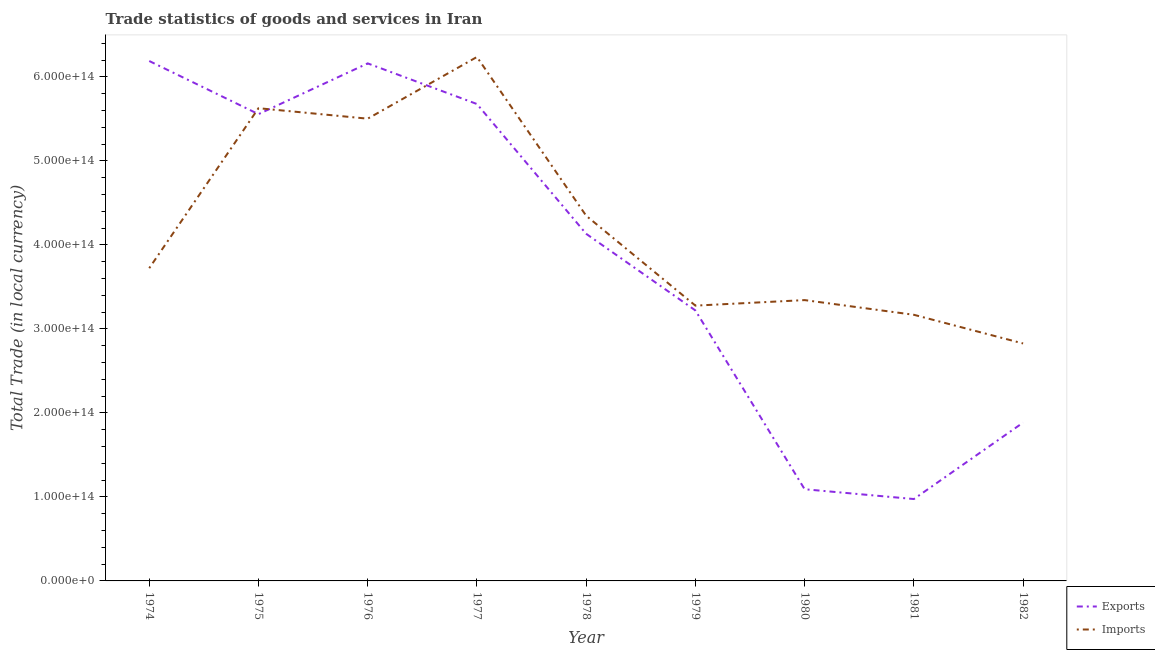Does the line corresponding to export of goods and services intersect with the line corresponding to imports of goods and services?
Your answer should be compact. Yes. What is the imports of goods and services in 1975?
Ensure brevity in your answer.  5.63e+14. Across all years, what is the maximum export of goods and services?
Offer a terse response. 6.19e+14. Across all years, what is the minimum export of goods and services?
Ensure brevity in your answer.  9.75e+13. In which year was the export of goods and services maximum?
Make the answer very short. 1974. What is the total imports of goods and services in the graph?
Your answer should be compact. 3.81e+15. What is the difference between the export of goods and services in 1974 and that in 1982?
Keep it short and to the point. 4.30e+14. What is the difference between the imports of goods and services in 1980 and the export of goods and services in 1979?
Make the answer very short. 1.23e+13. What is the average imports of goods and services per year?
Offer a terse response. 4.23e+14. In the year 1978, what is the difference between the export of goods and services and imports of goods and services?
Provide a succinct answer. -2.15e+13. In how many years, is the imports of goods and services greater than 40000000000000 LCU?
Give a very brief answer. 9. What is the ratio of the imports of goods and services in 1976 to that in 1981?
Your response must be concise. 1.74. Is the imports of goods and services in 1977 less than that in 1981?
Keep it short and to the point. No. What is the difference between the highest and the second highest export of goods and services?
Your answer should be compact. 2.84e+12. What is the difference between the highest and the lowest imports of goods and services?
Offer a terse response. 3.41e+14. Is the sum of the imports of goods and services in 1976 and 1977 greater than the maximum export of goods and services across all years?
Provide a short and direct response. Yes. Does the imports of goods and services monotonically increase over the years?
Your response must be concise. No. Is the export of goods and services strictly greater than the imports of goods and services over the years?
Keep it short and to the point. No. Is the export of goods and services strictly less than the imports of goods and services over the years?
Provide a short and direct response. No. How many lines are there?
Offer a terse response. 2. What is the difference between two consecutive major ticks on the Y-axis?
Give a very brief answer. 1.00e+14. Are the values on the major ticks of Y-axis written in scientific E-notation?
Give a very brief answer. Yes. What is the title of the graph?
Offer a very short reply. Trade statistics of goods and services in Iran. Does "Automatic Teller Machines" appear as one of the legend labels in the graph?
Provide a short and direct response. No. What is the label or title of the Y-axis?
Keep it short and to the point. Total Trade (in local currency). What is the Total Trade (in local currency) of Exports in 1974?
Your response must be concise. 6.19e+14. What is the Total Trade (in local currency) in Imports in 1974?
Provide a short and direct response. 3.72e+14. What is the Total Trade (in local currency) in Exports in 1975?
Your answer should be very brief. 5.56e+14. What is the Total Trade (in local currency) in Imports in 1975?
Your answer should be compact. 5.63e+14. What is the Total Trade (in local currency) of Exports in 1976?
Provide a succinct answer. 6.16e+14. What is the Total Trade (in local currency) in Imports in 1976?
Your response must be concise. 5.50e+14. What is the Total Trade (in local currency) in Exports in 1977?
Offer a very short reply. 5.68e+14. What is the Total Trade (in local currency) of Imports in 1977?
Your response must be concise. 6.24e+14. What is the Total Trade (in local currency) in Exports in 1978?
Provide a succinct answer. 4.13e+14. What is the Total Trade (in local currency) of Imports in 1978?
Keep it short and to the point. 4.35e+14. What is the Total Trade (in local currency) of Exports in 1979?
Ensure brevity in your answer.  3.22e+14. What is the Total Trade (in local currency) in Imports in 1979?
Offer a very short reply. 3.28e+14. What is the Total Trade (in local currency) of Exports in 1980?
Keep it short and to the point. 1.09e+14. What is the Total Trade (in local currency) of Imports in 1980?
Your answer should be very brief. 3.34e+14. What is the Total Trade (in local currency) in Exports in 1981?
Provide a short and direct response. 9.75e+13. What is the Total Trade (in local currency) of Imports in 1981?
Your response must be concise. 3.17e+14. What is the Total Trade (in local currency) in Exports in 1982?
Offer a very short reply. 1.88e+14. What is the Total Trade (in local currency) of Imports in 1982?
Your response must be concise. 2.83e+14. Across all years, what is the maximum Total Trade (in local currency) of Exports?
Your answer should be very brief. 6.19e+14. Across all years, what is the maximum Total Trade (in local currency) of Imports?
Keep it short and to the point. 6.24e+14. Across all years, what is the minimum Total Trade (in local currency) in Exports?
Offer a terse response. 9.75e+13. Across all years, what is the minimum Total Trade (in local currency) in Imports?
Offer a very short reply. 2.83e+14. What is the total Total Trade (in local currency) in Exports in the graph?
Provide a short and direct response. 3.49e+15. What is the total Total Trade (in local currency) of Imports in the graph?
Make the answer very short. 3.81e+15. What is the difference between the Total Trade (in local currency) of Exports in 1974 and that in 1975?
Make the answer very short. 6.33e+13. What is the difference between the Total Trade (in local currency) in Imports in 1974 and that in 1975?
Your response must be concise. -1.90e+14. What is the difference between the Total Trade (in local currency) of Exports in 1974 and that in 1976?
Keep it short and to the point. 2.84e+12. What is the difference between the Total Trade (in local currency) in Imports in 1974 and that in 1976?
Offer a terse response. -1.78e+14. What is the difference between the Total Trade (in local currency) of Exports in 1974 and that in 1977?
Make the answer very short. 5.12e+13. What is the difference between the Total Trade (in local currency) of Imports in 1974 and that in 1977?
Make the answer very short. -2.51e+14. What is the difference between the Total Trade (in local currency) in Exports in 1974 and that in 1978?
Keep it short and to the point. 2.06e+14. What is the difference between the Total Trade (in local currency) of Imports in 1974 and that in 1978?
Your response must be concise. -6.24e+13. What is the difference between the Total Trade (in local currency) in Exports in 1974 and that in 1979?
Provide a succinct answer. 2.97e+14. What is the difference between the Total Trade (in local currency) in Imports in 1974 and that in 1979?
Offer a terse response. 4.46e+13. What is the difference between the Total Trade (in local currency) of Exports in 1974 and that in 1980?
Keep it short and to the point. 5.10e+14. What is the difference between the Total Trade (in local currency) in Imports in 1974 and that in 1980?
Your answer should be very brief. 3.80e+13. What is the difference between the Total Trade (in local currency) in Exports in 1974 and that in 1981?
Provide a succinct answer. 5.21e+14. What is the difference between the Total Trade (in local currency) in Imports in 1974 and that in 1981?
Make the answer very short. 5.55e+13. What is the difference between the Total Trade (in local currency) in Exports in 1974 and that in 1982?
Ensure brevity in your answer.  4.30e+14. What is the difference between the Total Trade (in local currency) in Imports in 1974 and that in 1982?
Provide a short and direct response. 8.96e+13. What is the difference between the Total Trade (in local currency) of Exports in 1975 and that in 1976?
Make the answer very short. -6.04e+13. What is the difference between the Total Trade (in local currency) of Imports in 1975 and that in 1976?
Give a very brief answer. 1.25e+13. What is the difference between the Total Trade (in local currency) of Exports in 1975 and that in 1977?
Make the answer very short. -1.21e+13. What is the difference between the Total Trade (in local currency) of Imports in 1975 and that in 1977?
Offer a very short reply. -6.10e+13. What is the difference between the Total Trade (in local currency) of Exports in 1975 and that in 1978?
Offer a terse response. 1.42e+14. What is the difference between the Total Trade (in local currency) in Imports in 1975 and that in 1978?
Provide a succinct answer. 1.28e+14. What is the difference between the Total Trade (in local currency) of Exports in 1975 and that in 1979?
Offer a terse response. 2.34e+14. What is the difference between the Total Trade (in local currency) in Imports in 1975 and that in 1979?
Provide a short and direct response. 2.35e+14. What is the difference between the Total Trade (in local currency) in Exports in 1975 and that in 1980?
Make the answer very short. 4.47e+14. What is the difference between the Total Trade (in local currency) in Imports in 1975 and that in 1980?
Your answer should be compact. 2.28e+14. What is the difference between the Total Trade (in local currency) of Exports in 1975 and that in 1981?
Your response must be concise. 4.58e+14. What is the difference between the Total Trade (in local currency) of Imports in 1975 and that in 1981?
Provide a succinct answer. 2.46e+14. What is the difference between the Total Trade (in local currency) in Exports in 1975 and that in 1982?
Provide a short and direct response. 3.67e+14. What is the difference between the Total Trade (in local currency) in Imports in 1975 and that in 1982?
Make the answer very short. 2.80e+14. What is the difference between the Total Trade (in local currency) in Exports in 1976 and that in 1977?
Offer a very short reply. 4.84e+13. What is the difference between the Total Trade (in local currency) in Imports in 1976 and that in 1977?
Offer a terse response. -7.34e+13. What is the difference between the Total Trade (in local currency) of Exports in 1976 and that in 1978?
Ensure brevity in your answer.  2.03e+14. What is the difference between the Total Trade (in local currency) of Imports in 1976 and that in 1978?
Offer a terse response. 1.16e+14. What is the difference between the Total Trade (in local currency) of Exports in 1976 and that in 1979?
Your answer should be very brief. 2.94e+14. What is the difference between the Total Trade (in local currency) of Imports in 1976 and that in 1979?
Your response must be concise. 2.23e+14. What is the difference between the Total Trade (in local currency) in Exports in 1976 and that in 1980?
Make the answer very short. 5.07e+14. What is the difference between the Total Trade (in local currency) of Imports in 1976 and that in 1980?
Make the answer very short. 2.16e+14. What is the difference between the Total Trade (in local currency) of Exports in 1976 and that in 1981?
Offer a very short reply. 5.19e+14. What is the difference between the Total Trade (in local currency) of Imports in 1976 and that in 1981?
Your answer should be very brief. 2.33e+14. What is the difference between the Total Trade (in local currency) of Exports in 1976 and that in 1982?
Provide a succinct answer. 4.28e+14. What is the difference between the Total Trade (in local currency) of Imports in 1976 and that in 1982?
Offer a very short reply. 2.68e+14. What is the difference between the Total Trade (in local currency) of Exports in 1977 and that in 1978?
Offer a terse response. 1.55e+14. What is the difference between the Total Trade (in local currency) of Imports in 1977 and that in 1978?
Provide a succinct answer. 1.89e+14. What is the difference between the Total Trade (in local currency) of Exports in 1977 and that in 1979?
Offer a very short reply. 2.46e+14. What is the difference between the Total Trade (in local currency) of Imports in 1977 and that in 1979?
Make the answer very short. 2.96e+14. What is the difference between the Total Trade (in local currency) in Exports in 1977 and that in 1980?
Your answer should be compact. 4.59e+14. What is the difference between the Total Trade (in local currency) of Imports in 1977 and that in 1980?
Give a very brief answer. 2.89e+14. What is the difference between the Total Trade (in local currency) of Exports in 1977 and that in 1981?
Offer a terse response. 4.70e+14. What is the difference between the Total Trade (in local currency) in Imports in 1977 and that in 1981?
Offer a terse response. 3.07e+14. What is the difference between the Total Trade (in local currency) of Exports in 1977 and that in 1982?
Your answer should be very brief. 3.79e+14. What is the difference between the Total Trade (in local currency) in Imports in 1977 and that in 1982?
Provide a succinct answer. 3.41e+14. What is the difference between the Total Trade (in local currency) of Exports in 1978 and that in 1979?
Provide a short and direct response. 9.12e+13. What is the difference between the Total Trade (in local currency) in Imports in 1978 and that in 1979?
Offer a terse response. 1.07e+14. What is the difference between the Total Trade (in local currency) of Exports in 1978 and that in 1980?
Make the answer very short. 3.04e+14. What is the difference between the Total Trade (in local currency) in Imports in 1978 and that in 1980?
Keep it short and to the point. 1.00e+14. What is the difference between the Total Trade (in local currency) in Exports in 1978 and that in 1981?
Ensure brevity in your answer.  3.16e+14. What is the difference between the Total Trade (in local currency) in Imports in 1978 and that in 1981?
Offer a terse response. 1.18e+14. What is the difference between the Total Trade (in local currency) of Exports in 1978 and that in 1982?
Ensure brevity in your answer.  2.25e+14. What is the difference between the Total Trade (in local currency) in Imports in 1978 and that in 1982?
Offer a very short reply. 1.52e+14. What is the difference between the Total Trade (in local currency) in Exports in 1979 and that in 1980?
Offer a very short reply. 2.13e+14. What is the difference between the Total Trade (in local currency) in Imports in 1979 and that in 1980?
Provide a short and direct response. -6.57e+12. What is the difference between the Total Trade (in local currency) of Exports in 1979 and that in 1981?
Your response must be concise. 2.25e+14. What is the difference between the Total Trade (in local currency) of Imports in 1979 and that in 1981?
Your response must be concise. 1.09e+13. What is the difference between the Total Trade (in local currency) of Exports in 1979 and that in 1982?
Provide a short and direct response. 1.34e+14. What is the difference between the Total Trade (in local currency) in Imports in 1979 and that in 1982?
Provide a short and direct response. 4.51e+13. What is the difference between the Total Trade (in local currency) in Exports in 1980 and that in 1981?
Your answer should be compact. 1.17e+13. What is the difference between the Total Trade (in local currency) in Imports in 1980 and that in 1981?
Your answer should be compact. 1.75e+13. What is the difference between the Total Trade (in local currency) of Exports in 1980 and that in 1982?
Your response must be concise. -7.93e+13. What is the difference between the Total Trade (in local currency) in Imports in 1980 and that in 1982?
Give a very brief answer. 5.16e+13. What is the difference between the Total Trade (in local currency) in Exports in 1981 and that in 1982?
Your response must be concise. -9.10e+13. What is the difference between the Total Trade (in local currency) of Imports in 1981 and that in 1982?
Your answer should be compact. 3.41e+13. What is the difference between the Total Trade (in local currency) of Exports in 1974 and the Total Trade (in local currency) of Imports in 1975?
Ensure brevity in your answer.  5.62e+13. What is the difference between the Total Trade (in local currency) in Exports in 1974 and the Total Trade (in local currency) in Imports in 1976?
Provide a short and direct response. 6.87e+13. What is the difference between the Total Trade (in local currency) in Exports in 1974 and the Total Trade (in local currency) in Imports in 1977?
Your response must be concise. -4.80e+12. What is the difference between the Total Trade (in local currency) in Exports in 1974 and the Total Trade (in local currency) in Imports in 1978?
Offer a terse response. 1.84e+14. What is the difference between the Total Trade (in local currency) in Exports in 1974 and the Total Trade (in local currency) in Imports in 1979?
Keep it short and to the point. 2.91e+14. What is the difference between the Total Trade (in local currency) of Exports in 1974 and the Total Trade (in local currency) of Imports in 1980?
Your answer should be compact. 2.85e+14. What is the difference between the Total Trade (in local currency) of Exports in 1974 and the Total Trade (in local currency) of Imports in 1981?
Provide a short and direct response. 3.02e+14. What is the difference between the Total Trade (in local currency) in Exports in 1974 and the Total Trade (in local currency) in Imports in 1982?
Offer a terse response. 3.36e+14. What is the difference between the Total Trade (in local currency) of Exports in 1975 and the Total Trade (in local currency) of Imports in 1976?
Offer a very short reply. 5.38e+12. What is the difference between the Total Trade (in local currency) of Exports in 1975 and the Total Trade (in local currency) of Imports in 1977?
Offer a terse response. -6.81e+13. What is the difference between the Total Trade (in local currency) of Exports in 1975 and the Total Trade (in local currency) of Imports in 1978?
Offer a terse response. 1.21e+14. What is the difference between the Total Trade (in local currency) of Exports in 1975 and the Total Trade (in local currency) of Imports in 1979?
Offer a terse response. 2.28e+14. What is the difference between the Total Trade (in local currency) of Exports in 1975 and the Total Trade (in local currency) of Imports in 1980?
Your answer should be compact. 2.21e+14. What is the difference between the Total Trade (in local currency) of Exports in 1975 and the Total Trade (in local currency) of Imports in 1981?
Your answer should be compact. 2.39e+14. What is the difference between the Total Trade (in local currency) in Exports in 1975 and the Total Trade (in local currency) in Imports in 1982?
Your answer should be very brief. 2.73e+14. What is the difference between the Total Trade (in local currency) of Exports in 1976 and the Total Trade (in local currency) of Imports in 1977?
Make the answer very short. -7.63e+12. What is the difference between the Total Trade (in local currency) in Exports in 1976 and the Total Trade (in local currency) in Imports in 1978?
Provide a succinct answer. 1.81e+14. What is the difference between the Total Trade (in local currency) in Exports in 1976 and the Total Trade (in local currency) in Imports in 1979?
Make the answer very short. 2.88e+14. What is the difference between the Total Trade (in local currency) of Exports in 1976 and the Total Trade (in local currency) of Imports in 1980?
Your answer should be compact. 2.82e+14. What is the difference between the Total Trade (in local currency) of Exports in 1976 and the Total Trade (in local currency) of Imports in 1981?
Keep it short and to the point. 2.99e+14. What is the difference between the Total Trade (in local currency) in Exports in 1976 and the Total Trade (in local currency) in Imports in 1982?
Your answer should be compact. 3.33e+14. What is the difference between the Total Trade (in local currency) of Exports in 1977 and the Total Trade (in local currency) of Imports in 1978?
Offer a terse response. 1.33e+14. What is the difference between the Total Trade (in local currency) of Exports in 1977 and the Total Trade (in local currency) of Imports in 1979?
Provide a short and direct response. 2.40e+14. What is the difference between the Total Trade (in local currency) of Exports in 1977 and the Total Trade (in local currency) of Imports in 1980?
Your answer should be compact. 2.33e+14. What is the difference between the Total Trade (in local currency) in Exports in 1977 and the Total Trade (in local currency) in Imports in 1981?
Provide a short and direct response. 2.51e+14. What is the difference between the Total Trade (in local currency) in Exports in 1977 and the Total Trade (in local currency) in Imports in 1982?
Offer a terse response. 2.85e+14. What is the difference between the Total Trade (in local currency) in Exports in 1978 and the Total Trade (in local currency) in Imports in 1979?
Your response must be concise. 8.55e+13. What is the difference between the Total Trade (in local currency) in Exports in 1978 and the Total Trade (in local currency) in Imports in 1980?
Your answer should be very brief. 7.89e+13. What is the difference between the Total Trade (in local currency) in Exports in 1978 and the Total Trade (in local currency) in Imports in 1981?
Make the answer very short. 9.64e+13. What is the difference between the Total Trade (in local currency) in Exports in 1978 and the Total Trade (in local currency) in Imports in 1982?
Ensure brevity in your answer.  1.31e+14. What is the difference between the Total Trade (in local currency) in Exports in 1979 and the Total Trade (in local currency) in Imports in 1980?
Offer a terse response. -1.23e+13. What is the difference between the Total Trade (in local currency) in Exports in 1979 and the Total Trade (in local currency) in Imports in 1981?
Your response must be concise. 5.17e+12. What is the difference between the Total Trade (in local currency) in Exports in 1979 and the Total Trade (in local currency) in Imports in 1982?
Offer a very short reply. 3.93e+13. What is the difference between the Total Trade (in local currency) of Exports in 1980 and the Total Trade (in local currency) of Imports in 1981?
Offer a very short reply. -2.08e+14. What is the difference between the Total Trade (in local currency) of Exports in 1980 and the Total Trade (in local currency) of Imports in 1982?
Your response must be concise. -1.74e+14. What is the difference between the Total Trade (in local currency) of Exports in 1981 and the Total Trade (in local currency) of Imports in 1982?
Keep it short and to the point. -1.85e+14. What is the average Total Trade (in local currency) in Exports per year?
Give a very brief answer. 3.88e+14. What is the average Total Trade (in local currency) of Imports per year?
Keep it short and to the point. 4.23e+14. In the year 1974, what is the difference between the Total Trade (in local currency) in Exports and Total Trade (in local currency) in Imports?
Your answer should be compact. 2.47e+14. In the year 1975, what is the difference between the Total Trade (in local currency) of Exports and Total Trade (in local currency) of Imports?
Provide a succinct answer. -7.09e+12. In the year 1976, what is the difference between the Total Trade (in local currency) of Exports and Total Trade (in local currency) of Imports?
Provide a short and direct response. 6.58e+13. In the year 1977, what is the difference between the Total Trade (in local currency) in Exports and Total Trade (in local currency) in Imports?
Offer a terse response. -5.60e+13. In the year 1978, what is the difference between the Total Trade (in local currency) in Exports and Total Trade (in local currency) in Imports?
Keep it short and to the point. -2.15e+13. In the year 1979, what is the difference between the Total Trade (in local currency) of Exports and Total Trade (in local currency) of Imports?
Give a very brief answer. -5.74e+12. In the year 1980, what is the difference between the Total Trade (in local currency) in Exports and Total Trade (in local currency) in Imports?
Your answer should be compact. -2.25e+14. In the year 1981, what is the difference between the Total Trade (in local currency) in Exports and Total Trade (in local currency) in Imports?
Your response must be concise. -2.19e+14. In the year 1982, what is the difference between the Total Trade (in local currency) in Exports and Total Trade (in local currency) in Imports?
Offer a terse response. -9.42e+13. What is the ratio of the Total Trade (in local currency) in Exports in 1974 to that in 1975?
Your answer should be compact. 1.11. What is the ratio of the Total Trade (in local currency) of Imports in 1974 to that in 1975?
Offer a very short reply. 0.66. What is the ratio of the Total Trade (in local currency) in Imports in 1974 to that in 1976?
Provide a succinct answer. 0.68. What is the ratio of the Total Trade (in local currency) of Exports in 1974 to that in 1977?
Offer a very short reply. 1.09. What is the ratio of the Total Trade (in local currency) in Imports in 1974 to that in 1977?
Give a very brief answer. 0.6. What is the ratio of the Total Trade (in local currency) of Exports in 1974 to that in 1978?
Your response must be concise. 1.5. What is the ratio of the Total Trade (in local currency) of Imports in 1974 to that in 1978?
Your answer should be very brief. 0.86. What is the ratio of the Total Trade (in local currency) in Exports in 1974 to that in 1979?
Ensure brevity in your answer.  1.92. What is the ratio of the Total Trade (in local currency) in Imports in 1974 to that in 1979?
Offer a terse response. 1.14. What is the ratio of the Total Trade (in local currency) of Exports in 1974 to that in 1980?
Your answer should be very brief. 5.67. What is the ratio of the Total Trade (in local currency) in Imports in 1974 to that in 1980?
Offer a very short reply. 1.11. What is the ratio of the Total Trade (in local currency) of Exports in 1974 to that in 1981?
Ensure brevity in your answer.  6.35. What is the ratio of the Total Trade (in local currency) in Imports in 1974 to that in 1981?
Keep it short and to the point. 1.18. What is the ratio of the Total Trade (in local currency) of Exports in 1974 to that in 1982?
Offer a terse response. 3.28. What is the ratio of the Total Trade (in local currency) of Imports in 1974 to that in 1982?
Your response must be concise. 1.32. What is the ratio of the Total Trade (in local currency) in Exports in 1975 to that in 1976?
Offer a very short reply. 0.9. What is the ratio of the Total Trade (in local currency) of Imports in 1975 to that in 1976?
Give a very brief answer. 1.02. What is the ratio of the Total Trade (in local currency) of Exports in 1975 to that in 1977?
Your response must be concise. 0.98. What is the ratio of the Total Trade (in local currency) in Imports in 1975 to that in 1977?
Your answer should be compact. 0.9. What is the ratio of the Total Trade (in local currency) of Exports in 1975 to that in 1978?
Provide a succinct answer. 1.34. What is the ratio of the Total Trade (in local currency) of Imports in 1975 to that in 1978?
Provide a short and direct response. 1.29. What is the ratio of the Total Trade (in local currency) in Exports in 1975 to that in 1979?
Give a very brief answer. 1.73. What is the ratio of the Total Trade (in local currency) of Imports in 1975 to that in 1979?
Your answer should be compact. 1.72. What is the ratio of the Total Trade (in local currency) in Exports in 1975 to that in 1980?
Offer a very short reply. 5.09. What is the ratio of the Total Trade (in local currency) in Imports in 1975 to that in 1980?
Make the answer very short. 1.68. What is the ratio of the Total Trade (in local currency) in Exports in 1975 to that in 1981?
Your response must be concise. 5.7. What is the ratio of the Total Trade (in local currency) of Imports in 1975 to that in 1981?
Ensure brevity in your answer.  1.78. What is the ratio of the Total Trade (in local currency) in Exports in 1975 to that in 1982?
Ensure brevity in your answer.  2.95. What is the ratio of the Total Trade (in local currency) in Imports in 1975 to that in 1982?
Offer a very short reply. 1.99. What is the ratio of the Total Trade (in local currency) of Exports in 1976 to that in 1977?
Give a very brief answer. 1.09. What is the ratio of the Total Trade (in local currency) of Imports in 1976 to that in 1977?
Make the answer very short. 0.88. What is the ratio of the Total Trade (in local currency) of Exports in 1976 to that in 1978?
Make the answer very short. 1.49. What is the ratio of the Total Trade (in local currency) in Imports in 1976 to that in 1978?
Make the answer very short. 1.27. What is the ratio of the Total Trade (in local currency) in Exports in 1976 to that in 1979?
Your answer should be compact. 1.91. What is the ratio of the Total Trade (in local currency) of Imports in 1976 to that in 1979?
Make the answer very short. 1.68. What is the ratio of the Total Trade (in local currency) in Exports in 1976 to that in 1980?
Give a very brief answer. 5.64. What is the ratio of the Total Trade (in local currency) of Imports in 1976 to that in 1980?
Provide a succinct answer. 1.65. What is the ratio of the Total Trade (in local currency) of Exports in 1976 to that in 1981?
Provide a succinct answer. 6.32. What is the ratio of the Total Trade (in local currency) in Imports in 1976 to that in 1981?
Your answer should be very brief. 1.74. What is the ratio of the Total Trade (in local currency) of Exports in 1976 to that in 1982?
Keep it short and to the point. 3.27. What is the ratio of the Total Trade (in local currency) in Imports in 1976 to that in 1982?
Ensure brevity in your answer.  1.95. What is the ratio of the Total Trade (in local currency) of Exports in 1977 to that in 1978?
Keep it short and to the point. 1.37. What is the ratio of the Total Trade (in local currency) of Imports in 1977 to that in 1978?
Your answer should be compact. 1.43. What is the ratio of the Total Trade (in local currency) of Exports in 1977 to that in 1979?
Provide a succinct answer. 1.76. What is the ratio of the Total Trade (in local currency) of Imports in 1977 to that in 1979?
Offer a very short reply. 1.9. What is the ratio of the Total Trade (in local currency) in Exports in 1977 to that in 1980?
Your answer should be very brief. 5.2. What is the ratio of the Total Trade (in local currency) in Imports in 1977 to that in 1980?
Ensure brevity in your answer.  1.87. What is the ratio of the Total Trade (in local currency) of Exports in 1977 to that in 1981?
Ensure brevity in your answer.  5.82. What is the ratio of the Total Trade (in local currency) of Imports in 1977 to that in 1981?
Make the answer very short. 1.97. What is the ratio of the Total Trade (in local currency) in Exports in 1977 to that in 1982?
Give a very brief answer. 3.01. What is the ratio of the Total Trade (in local currency) of Imports in 1977 to that in 1982?
Your answer should be very brief. 2.21. What is the ratio of the Total Trade (in local currency) in Exports in 1978 to that in 1979?
Provide a succinct answer. 1.28. What is the ratio of the Total Trade (in local currency) of Imports in 1978 to that in 1979?
Offer a terse response. 1.33. What is the ratio of the Total Trade (in local currency) of Exports in 1978 to that in 1980?
Offer a very short reply. 3.79. What is the ratio of the Total Trade (in local currency) of Imports in 1978 to that in 1980?
Your answer should be compact. 1.3. What is the ratio of the Total Trade (in local currency) of Exports in 1978 to that in 1981?
Make the answer very short. 4.24. What is the ratio of the Total Trade (in local currency) of Imports in 1978 to that in 1981?
Your response must be concise. 1.37. What is the ratio of the Total Trade (in local currency) in Exports in 1978 to that in 1982?
Give a very brief answer. 2.19. What is the ratio of the Total Trade (in local currency) in Imports in 1978 to that in 1982?
Provide a succinct answer. 1.54. What is the ratio of the Total Trade (in local currency) in Exports in 1979 to that in 1980?
Make the answer very short. 2.95. What is the ratio of the Total Trade (in local currency) of Imports in 1979 to that in 1980?
Make the answer very short. 0.98. What is the ratio of the Total Trade (in local currency) of Exports in 1979 to that in 1981?
Your response must be concise. 3.3. What is the ratio of the Total Trade (in local currency) in Imports in 1979 to that in 1981?
Make the answer very short. 1.03. What is the ratio of the Total Trade (in local currency) of Exports in 1979 to that in 1982?
Give a very brief answer. 1.71. What is the ratio of the Total Trade (in local currency) in Imports in 1979 to that in 1982?
Your answer should be very brief. 1.16. What is the ratio of the Total Trade (in local currency) in Exports in 1980 to that in 1981?
Provide a succinct answer. 1.12. What is the ratio of the Total Trade (in local currency) of Imports in 1980 to that in 1981?
Provide a succinct answer. 1.06. What is the ratio of the Total Trade (in local currency) of Exports in 1980 to that in 1982?
Ensure brevity in your answer.  0.58. What is the ratio of the Total Trade (in local currency) in Imports in 1980 to that in 1982?
Provide a short and direct response. 1.18. What is the ratio of the Total Trade (in local currency) in Exports in 1981 to that in 1982?
Offer a terse response. 0.52. What is the ratio of the Total Trade (in local currency) of Imports in 1981 to that in 1982?
Provide a succinct answer. 1.12. What is the difference between the highest and the second highest Total Trade (in local currency) of Exports?
Keep it short and to the point. 2.84e+12. What is the difference between the highest and the second highest Total Trade (in local currency) in Imports?
Offer a terse response. 6.10e+13. What is the difference between the highest and the lowest Total Trade (in local currency) in Exports?
Your response must be concise. 5.21e+14. What is the difference between the highest and the lowest Total Trade (in local currency) in Imports?
Make the answer very short. 3.41e+14. 